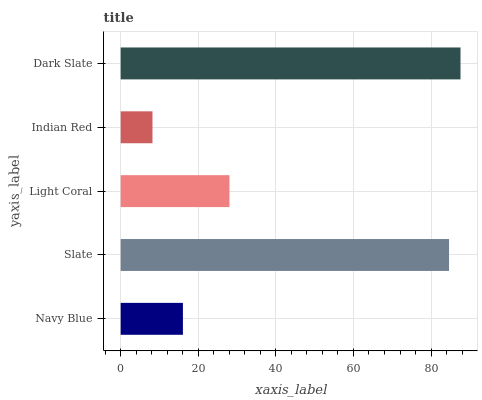Is Indian Red the minimum?
Answer yes or no. Yes. Is Dark Slate the maximum?
Answer yes or no. Yes. Is Slate the minimum?
Answer yes or no. No. Is Slate the maximum?
Answer yes or no. No. Is Slate greater than Navy Blue?
Answer yes or no. Yes. Is Navy Blue less than Slate?
Answer yes or no. Yes. Is Navy Blue greater than Slate?
Answer yes or no. No. Is Slate less than Navy Blue?
Answer yes or no. No. Is Light Coral the high median?
Answer yes or no. Yes. Is Light Coral the low median?
Answer yes or no. Yes. Is Dark Slate the high median?
Answer yes or no. No. Is Slate the low median?
Answer yes or no. No. 